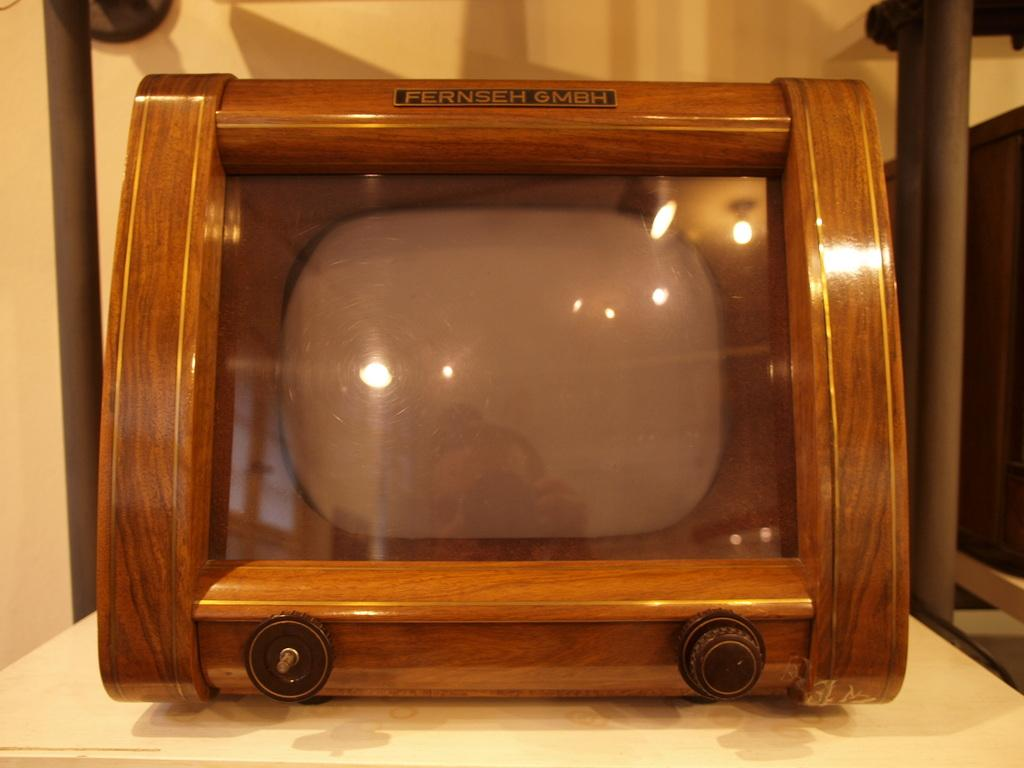<image>
Render a clear and concise summary of the photo. The old FERNSEH GMBH TV is encased in wood instead of plastic. 